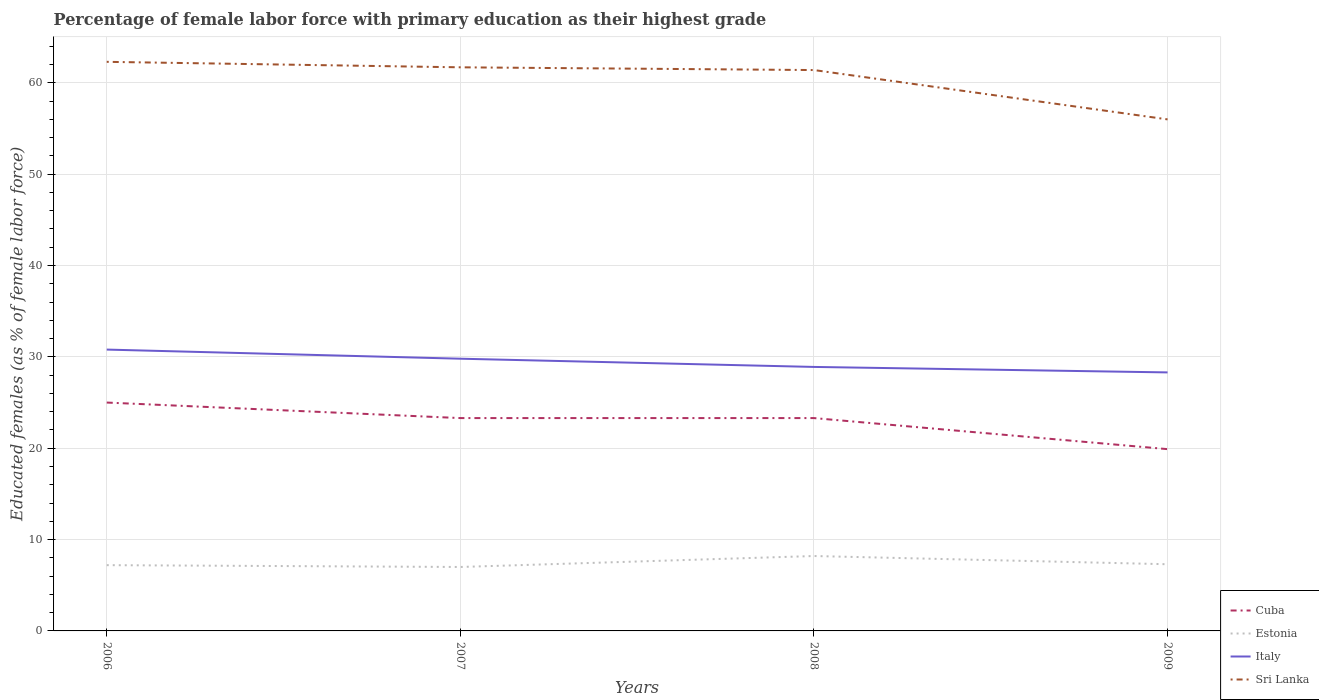How many different coloured lines are there?
Make the answer very short. 4. Does the line corresponding to Estonia intersect with the line corresponding to Sri Lanka?
Give a very brief answer. No. Across all years, what is the maximum percentage of female labor force with primary education in Italy?
Keep it short and to the point. 28.3. What is the total percentage of female labor force with primary education in Sri Lanka in the graph?
Offer a terse response. 0.9. What is the difference between the highest and the second highest percentage of female labor force with primary education in Estonia?
Offer a very short reply. 1.2. Is the percentage of female labor force with primary education in Estonia strictly greater than the percentage of female labor force with primary education in Cuba over the years?
Your answer should be very brief. Yes. How many years are there in the graph?
Offer a terse response. 4. Are the values on the major ticks of Y-axis written in scientific E-notation?
Keep it short and to the point. No. Where does the legend appear in the graph?
Keep it short and to the point. Bottom right. How are the legend labels stacked?
Give a very brief answer. Vertical. What is the title of the graph?
Make the answer very short. Percentage of female labor force with primary education as their highest grade. Does "Jordan" appear as one of the legend labels in the graph?
Provide a succinct answer. No. What is the label or title of the X-axis?
Your response must be concise. Years. What is the label or title of the Y-axis?
Make the answer very short. Educated females (as % of female labor force). What is the Educated females (as % of female labor force) of Cuba in 2006?
Ensure brevity in your answer.  25. What is the Educated females (as % of female labor force) of Estonia in 2006?
Your answer should be compact. 7.2. What is the Educated females (as % of female labor force) of Italy in 2006?
Ensure brevity in your answer.  30.8. What is the Educated females (as % of female labor force) of Sri Lanka in 2006?
Ensure brevity in your answer.  62.3. What is the Educated females (as % of female labor force) of Cuba in 2007?
Your answer should be very brief. 23.3. What is the Educated females (as % of female labor force) of Italy in 2007?
Offer a terse response. 29.8. What is the Educated females (as % of female labor force) of Sri Lanka in 2007?
Keep it short and to the point. 61.7. What is the Educated females (as % of female labor force) in Cuba in 2008?
Your answer should be compact. 23.3. What is the Educated females (as % of female labor force) of Estonia in 2008?
Offer a very short reply. 8.2. What is the Educated females (as % of female labor force) of Italy in 2008?
Your answer should be compact. 28.9. What is the Educated females (as % of female labor force) in Sri Lanka in 2008?
Offer a terse response. 61.4. What is the Educated females (as % of female labor force) of Cuba in 2009?
Your answer should be compact. 19.9. What is the Educated females (as % of female labor force) in Estonia in 2009?
Offer a terse response. 7.3. What is the Educated females (as % of female labor force) in Italy in 2009?
Keep it short and to the point. 28.3. What is the Educated females (as % of female labor force) of Sri Lanka in 2009?
Provide a succinct answer. 56. Across all years, what is the maximum Educated females (as % of female labor force) of Cuba?
Give a very brief answer. 25. Across all years, what is the maximum Educated females (as % of female labor force) in Estonia?
Your response must be concise. 8.2. Across all years, what is the maximum Educated females (as % of female labor force) in Italy?
Provide a short and direct response. 30.8. Across all years, what is the maximum Educated females (as % of female labor force) of Sri Lanka?
Provide a short and direct response. 62.3. Across all years, what is the minimum Educated females (as % of female labor force) in Cuba?
Keep it short and to the point. 19.9. Across all years, what is the minimum Educated females (as % of female labor force) of Italy?
Provide a succinct answer. 28.3. Across all years, what is the minimum Educated females (as % of female labor force) of Sri Lanka?
Ensure brevity in your answer.  56. What is the total Educated females (as % of female labor force) in Cuba in the graph?
Ensure brevity in your answer.  91.5. What is the total Educated females (as % of female labor force) in Estonia in the graph?
Keep it short and to the point. 29.7. What is the total Educated females (as % of female labor force) in Italy in the graph?
Your answer should be very brief. 117.8. What is the total Educated females (as % of female labor force) of Sri Lanka in the graph?
Offer a very short reply. 241.4. What is the difference between the Educated females (as % of female labor force) of Cuba in 2006 and that in 2007?
Offer a very short reply. 1.7. What is the difference between the Educated females (as % of female labor force) in Sri Lanka in 2006 and that in 2007?
Provide a succinct answer. 0.6. What is the difference between the Educated females (as % of female labor force) of Estonia in 2006 and that in 2008?
Offer a very short reply. -1. What is the difference between the Educated females (as % of female labor force) of Italy in 2006 and that in 2008?
Offer a very short reply. 1.9. What is the difference between the Educated females (as % of female labor force) of Sri Lanka in 2006 and that in 2008?
Keep it short and to the point. 0.9. What is the difference between the Educated females (as % of female labor force) in Cuba in 2006 and that in 2009?
Make the answer very short. 5.1. What is the difference between the Educated females (as % of female labor force) in Italy in 2006 and that in 2009?
Give a very brief answer. 2.5. What is the difference between the Educated females (as % of female labor force) in Sri Lanka in 2006 and that in 2009?
Keep it short and to the point. 6.3. What is the difference between the Educated females (as % of female labor force) in Sri Lanka in 2007 and that in 2008?
Make the answer very short. 0.3. What is the difference between the Educated females (as % of female labor force) of Cuba in 2007 and that in 2009?
Your response must be concise. 3.4. What is the difference between the Educated females (as % of female labor force) in Italy in 2007 and that in 2009?
Make the answer very short. 1.5. What is the difference between the Educated females (as % of female labor force) of Cuba in 2008 and that in 2009?
Provide a succinct answer. 3.4. What is the difference between the Educated females (as % of female labor force) in Estonia in 2008 and that in 2009?
Offer a very short reply. 0.9. What is the difference between the Educated females (as % of female labor force) in Sri Lanka in 2008 and that in 2009?
Your answer should be compact. 5.4. What is the difference between the Educated females (as % of female labor force) of Cuba in 2006 and the Educated females (as % of female labor force) of Sri Lanka in 2007?
Your response must be concise. -36.7. What is the difference between the Educated females (as % of female labor force) in Estonia in 2006 and the Educated females (as % of female labor force) in Italy in 2007?
Offer a terse response. -22.6. What is the difference between the Educated females (as % of female labor force) in Estonia in 2006 and the Educated females (as % of female labor force) in Sri Lanka in 2007?
Make the answer very short. -54.5. What is the difference between the Educated females (as % of female labor force) in Italy in 2006 and the Educated females (as % of female labor force) in Sri Lanka in 2007?
Your answer should be compact. -30.9. What is the difference between the Educated females (as % of female labor force) in Cuba in 2006 and the Educated females (as % of female labor force) in Italy in 2008?
Make the answer very short. -3.9. What is the difference between the Educated females (as % of female labor force) of Cuba in 2006 and the Educated females (as % of female labor force) of Sri Lanka in 2008?
Offer a terse response. -36.4. What is the difference between the Educated females (as % of female labor force) in Estonia in 2006 and the Educated females (as % of female labor force) in Italy in 2008?
Provide a short and direct response. -21.7. What is the difference between the Educated females (as % of female labor force) in Estonia in 2006 and the Educated females (as % of female labor force) in Sri Lanka in 2008?
Give a very brief answer. -54.2. What is the difference between the Educated females (as % of female labor force) of Italy in 2006 and the Educated females (as % of female labor force) of Sri Lanka in 2008?
Your answer should be very brief. -30.6. What is the difference between the Educated females (as % of female labor force) in Cuba in 2006 and the Educated females (as % of female labor force) in Estonia in 2009?
Your response must be concise. 17.7. What is the difference between the Educated females (as % of female labor force) of Cuba in 2006 and the Educated females (as % of female labor force) of Sri Lanka in 2009?
Your answer should be compact. -31. What is the difference between the Educated females (as % of female labor force) in Estonia in 2006 and the Educated females (as % of female labor force) in Italy in 2009?
Keep it short and to the point. -21.1. What is the difference between the Educated females (as % of female labor force) of Estonia in 2006 and the Educated females (as % of female labor force) of Sri Lanka in 2009?
Make the answer very short. -48.8. What is the difference between the Educated females (as % of female labor force) of Italy in 2006 and the Educated females (as % of female labor force) of Sri Lanka in 2009?
Provide a short and direct response. -25.2. What is the difference between the Educated females (as % of female labor force) in Cuba in 2007 and the Educated females (as % of female labor force) in Estonia in 2008?
Offer a terse response. 15.1. What is the difference between the Educated females (as % of female labor force) of Cuba in 2007 and the Educated females (as % of female labor force) of Sri Lanka in 2008?
Make the answer very short. -38.1. What is the difference between the Educated females (as % of female labor force) in Estonia in 2007 and the Educated females (as % of female labor force) in Italy in 2008?
Give a very brief answer. -21.9. What is the difference between the Educated females (as % of female labor force) of Estonia in 2007 and the Educated females (as % of female labor force) of Sri Lanka in 2008?
Your answer should be compact. -54.4. What is the difference between the Educated females (as % of female labor force) in Italy in 2007 and the Educated females (as % of female labor force) in Sri Lanka in 2008?
Make the answer very short. -31.6. What is the difference between the Educated females (as % of female labor force) in Cuba in 2007 and the Educated females (as % of female labor force) in Italy in 2009?
Offer a very short reply. -5. What is the difference between the Educated females (as % of female labor force) in Cuba in 2007 and the Educated females (as % of female labor force) in Sri Lanka in 2009?
Offer a very short reply. -32.7. What is the difference between the Educated females (as % of female labor force) in Estonia in 2007 and the Educated females (as % of female labor force) in Italy in 2009?
Your answer should be compact. -21.3. What is the difference between the Educated females (as % of female labor force) in Estonia in 2007 and the Educated females (as % of female labor force) in Sri Lanka in 2009?
Provide a short and direct response. -49. What is the difference between the Educated females (as % of female labor force) of Italy in 2007 and the Educated females (as % of female labor force) of Sri Lanka in 2009?
Keep it short and to the point. -26.2. What is the difference between the Educated females (as % of female labor force) of Cuba in 2008 and the Educated females (as % of female labor force) of Italy in 2009?
Your answer should be very brief. -5. What is the difference between the Educated females (as % of female labor force) of Cuba in 2008 and the Educated females (as % of female labor force) of Sri Lanka in 2009?
Provide a short and direct response. -32.7. What is the difference between the Educated females (as % of female labor force) of Estonia in 2008 and the Educated females (as % of female labor force) of Italy in 2009?
Keep it short and to the point. -20.1. What is the difference between the Educated females (as % of female labor force) in Estonia in 2008 and the Educated females (as % of female labor force) in Sri Lanka in 2009?
Provide a short and direct response. -47.8. What is the difference between the Educated females (as % of female labor force) of Italy in 2008 and the Educated females (as % of female labor force) of Sri Lanka in 2009?
Keep it short and to the point. -27.1. What is the average Educated females (as % of female labor force) of Cuba per year?
Keep it short and to the point. 22.88. What is the average Educated females (as % of female labor force) of Estonia per year?
Ensure brevity in your answer.  7.42. What is the average Educated females (as % of female labor force) of Italy per year?
Your answer should be compact. 29.45. What is the average Educated females (as % of female labor force) in Sri Lanka per year?
Give a very brief answer. 60.35. In the year 2006, what is the difference between the Educated females (as % of female labor force) in Cuba and Educated females (as % of female labor force) in Italy?
Your answer should be very brief. -5.8. In the year 2006, what is the difference between the Educated females (as % of female labor force) of Cuba and Educated females (as % of female labor force) of Sri Lanka?
Your answer should be compact. -37.3. In the year 2006, what is the difference between the Educated females (as % of female labor force) of Estonia and Educated females (as % of female labor force) of Italy?
Ensure brevity in your answer.  -23.6. In the year 2006, what is the difference between the Educated females (as % of female labor force) in Estonia and Educated females (as % of female labor force) in Sri Lanka?
Provide a succinct answer. -55.1. In the year 2006, what is the difference between the Educated females (as % of female labor force) of Italy and Educated females (as % of female labor force) of Sri Lanka?
Offer a very short reply. -31.5. In the year 2007, what is the difference between the Educated females (as % of female labor force) in Cuba and Educated females (as % of female labor force) in Estonia?
Provide a short and direct response. 16.3. In the year 2007, what is the difference between the Educated females (as % of female labor force) of Cuba and Educated females (as % of female labor force) of Sri Lanka?
Offer a very short reply. -38.4. In the year 2007, what is the difference between the Educated females (as % of female labor force) of Estonia and Educated females (as % of female labor force) of Italy?
Your answer should be compact. -22.8. In the year 2007, what is the difference between the Educated females (as % of female labor force) of Estonia and Educated females (as % of female labor force) of Sri Lanka?
Offer a very short reply. -54.7. In the year 2007, what is the difference between the Educated females (as % of female labor force) of Italy and Educated females (as % of female labor force) of Sri Lanka?
Make the answer very short. -31.9. In the year 2008, what is the difference between the Educated females (as % of female labor force) in Cuba and Educated females (as % of female labor force) in Italy?
Provide a short and direct response. -5.6. In the year 2008, what is the difference between the Educated females (as % of female labor force) of Cuba and Educated females (as % of female labor force) of Sri Lanka?
Make the answer very short. -38.1. In the year 2008, what is the difference between the Educated females (as % of female labor force) of Estonia and Educated females (as % of female labor force) of Italy?
Keep it short and to the point. -20.7. In the year 2008, what is the difference between the Educated females (as % of female labor force) of Estonia and Educated females (as % of female labor force) of Sri Lanka?
Provide a short and direct response. -53.2. In the year 2008, what is the difference between the Educated females (as % of female labor force) of Italy and Educated females (as % of female labor force) of Sri Lanka?
Offer a very short reply. -32.5. In the year 2009, what is the difference between the Educated females (as % of female labor force) in Cuba and Educated females (as % of female labor force) in Estonia?
Provide a short and direct response. 12.6. In the year 2009, what is the difference between the Educated females (as % of female labor force) of Cuba and Educated females (as % of female labor force) of Sri Lanka?
Your answer should be very brief. -36.1. In the year 2009, what is the difference between the Educated females (as % of female labor force) of Estonia and Educated females (as % of female labor force) of Italy?
Keep it short and to the point. -21. In the year 2009, what is the difference between the Educated females (as % of female labor force) in Estonia and Educated females (as % of female labor force) in Sri Lanka?
Your answer should be very brief. -48.7. In the year 2009, what is the difference between the Educated females (as % of female labor force) of Italy and Educated females (as % of female labor force) of Sri Lanka?
Your answer should be very brief. -27.7. What is the ratio of the Educated females (as % of female labor force) in Cuba in 2006 to that in 2007?
Offer a very short reply. 1.07. What is the ratio of the Educated females (as % of female labor force) of Estonia in 2006 to that in 2007?
Give a very brief answer. 1.03. What is the ratio of the Educated females (as % of female labor force) in Italy in 2006 to that in 2007?
Give a very brief answer. 1.03. What is the ratio of the Educated females (as % of female labor force) in Sri Lanka in 2006 to that in 2007?
Keep it short and to the point. 1.01. What is the ratio of the Educated females (as % of female labor force) in Cuba in 2006 to that in 2008?
Offer a terse response. 1.07. What is the ratio of the Educated females (as % of female labor force) in Estonia in 2006 to that in 2008?
Ensure brevity in your answer.  0.88. What is the ratio of the Educated females (as % of female labor force) in Italy in 2006 to that in 2008?
Make the answer very short. 1.07. What is the ratio of the Educated females (as % of female labor force) of Sri Lanka in 2006 to that in 2008?
Give a very brief answer. 1.01. What is the ratio of the Educated females (as % of female labor force) of Cuba in 2006 to that in 2009?
Your answer should be very brief. 1.26. What is the ratio of the Educated females (as % of female labor force) in Estonia in 2006 to that in 2009?
Your response must be concise. 0.99. What is the ratio of the Educated females (as % of female labor force) of Italy in 2006 to that in 2009?
Make the answer very short. 1.09. What is the ratio of the Educated females (as % of female labor force) in Sri Lanka in 2006 to that in 2009?
Offer a very short reply. 1.11. What is the ratio of the Educated females (as % of female labor force) in Estonia in 2007 to that in 2008?
Your answer should be very brief. 0.85. What is the ratio of the Educated females (as % of female labor force) in Italy in 2007 to that in 2008?
Ensure brevity in your answer.  1.03. What is the ratio of the Educated females (as % of female labor force) in Sri Lanka in 2007 to that in 2008?
Provide a succinct answer. 1. What is the ratio of the Educated females (as % of female labor force) of Cuba in 2007 to that in 2009?
Provide a short and direct response. 1.17. What is the ratio of the Educated females (as % of female labor force) of Estonia in 2007 to that in 2009?
Provide a short and direct response. 0.96. What is the ratio of the Educated females (as % of female labor force) in Italy in 2007 to that in 2009?
Offer a very short reply. 1.05. What is the ratio of the Educated females (as % of female labor force) of Sri Lanka in 2007 to that in 2009?
Your answer should be compact. 1.1. What is the ratio of the Educated females (as % of female labor force) in Cuba in 2008 to that in 2009?
Give a very brief answer. 1.17. What is the ratio of the Educated females (as % of female labor force) of Estonia in 2008 to that in 2009?
Make the answer very short. 1.12. What is the ratio of the Educated females (as % of female labor force) of Italy in 2008 to that in 2009?
Ensure brevity in your answer.  1.02. What is the ratio of the Educated females (as % of female labor force) in Sri Lanka in 2008 to that in 2009?
Ensure brevity in your answer.  1.1. What is the difference between the highest and the second highest Educated females (as % of female labor force) of Cuba?
Make the answer very short. 1.7. What is the difference between the highest and the second highest Educated females (as % of female labor force) in Italy?
Provide a succinct answer. 1. What is the difference between the highest and the lowest Educated females (as % of female labor force) of Italy?
Provide a short and direct response. 2.5. 